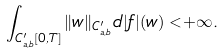Convert formula to latex. <formula><loc_0><loc_0><loc_500><loc_500>\int _ { C _ { a , b } ^ { \prime } [ 0 , T ] } \| w \| _ { C _ { a , b } ^ { \prime } } d | f | ( w ) < + \infty .</formula> 